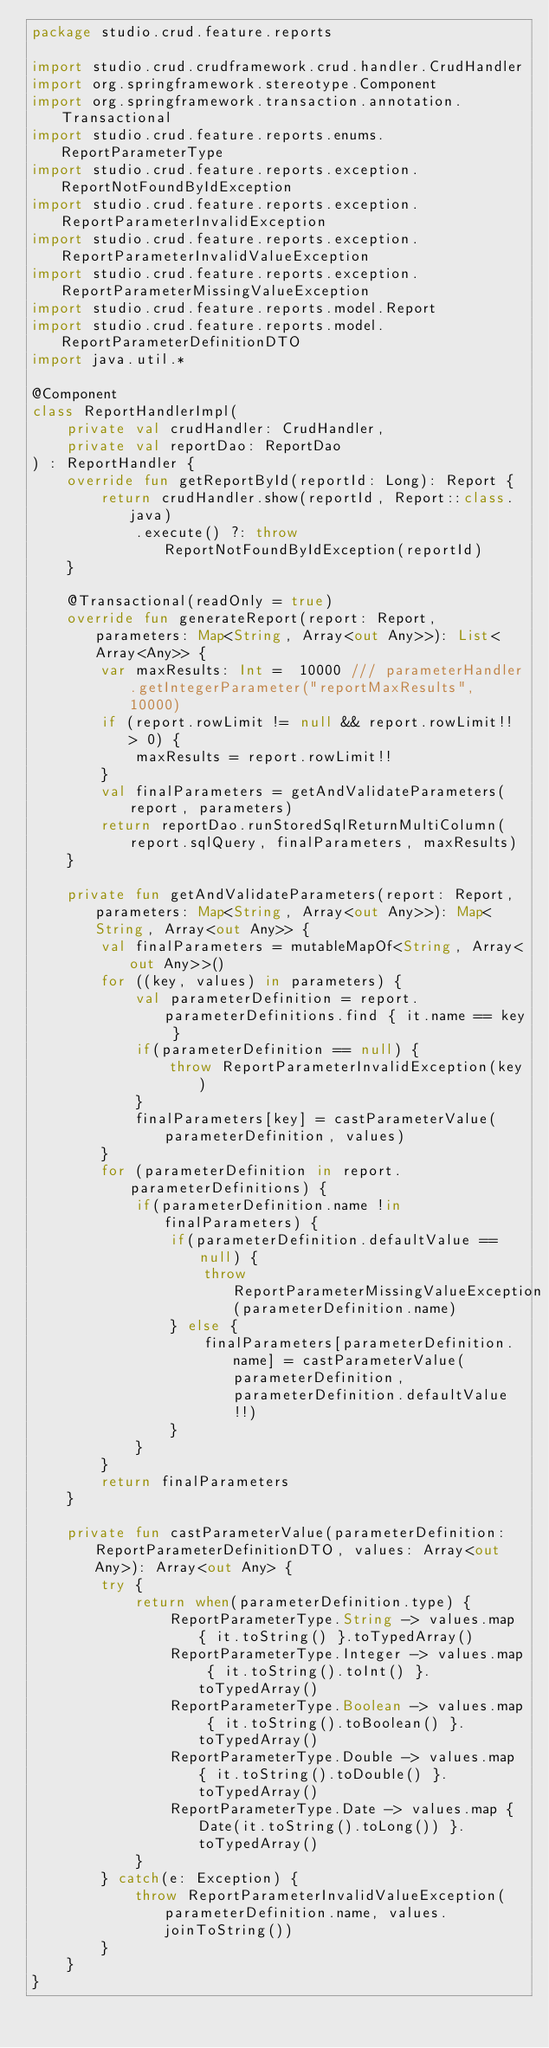<code> <loc_0><loc_0><loc_500><loc_500><_Kotlin_>package studio.crud.feature.reports

import studio.crud.crudframework.crud.handler.CrudHandler
import org.springframework.stereotype.Component
import org.springframework.transaction.annotation.Transactional
import studio.crud.feature.reports.enums.ReportParameterType
import studio.crud.feature.reports.exception.ReportNotFoundByIdException
import studio.crud.feature.reports.exception.ReportParameterInvalidException
import studio.crud.feature.reports.exception.ReportParameterInvalidValueException
import studio.crud.feature.reports.exception.ReportParameterMissingValueException
import studio.crud.feature.reports.model.Report
import studio.crud.feature.reports.model.ReportParameterDefinitionDTO
import java.util.*

@Component
class ReportHandlerImpl(
    private val crudHandler: CrudHandler,
    private val reportDao: ReportDao
) : ReportHandler {
    override fun getReportById(reportId: Long): Report {
        return crudHandler.show(reportId, Report::class.java)
            .execute() ?: throw ReportNotFoundByIdException(reportId)
    }

    @Transactional(readOnly = true)
    override fun generateReport(report: Report, parameters: Map<String, Array<out Any>>): List<Array<Any>> {
        var maxResults: Int =  10000 /// parameterHandler.getIntegerParameter("reportMaxResults", 10000)
        if (report.rowLimit != null && report.rowLimit!! > 0) {
            maxResults = report.rowLimit!!
        }
        val finalParameters = getAndValidateParameters(report, parameters)
        return reportDao.runStoredSqlReturnMultiColumn(report.sqlQuery, finalParameters, maxResults)
    }

    private fun getAndValidateParameters(report: Report, parameters: Map<String, Array<out Any>>): Map<String, Array<out Any>> {
        val finalParameters = mutableMapOf<String, Array<out Any>>()
        for ((key, values) in parameters) {
            val parameterDefinition = report.parameterDefinitions.find { it.name == key }
            if(parameterDefinition == null) {
                throw ReportParameterInvalidException(key)
            }
            finalParameters[key] = castParameterValue(parameterDefinition, values)
        }
        for (parameterDefinition in report.parameterDefinitions) {
            if(parameterDefinition.name !in finalParameters) {
                if(parameterDefinition.defaultValue == null) {
                    throw ReportParameterMissingValueException(parameterDefinition.name)
                } else {
                    finalParameters[parameterDefinition.name] = castParameterValue(parameterDefinition, parameterDefinition.defaultValue!!)
                }
            }
        }
        return finalParameters
    }

    private fun castParameterValue(parameterDefinition: ReportParameterDefinitionDTO, values: Array<out Any>): Array<out Any> {
        try {
            return when(parameterDefinition.type) {
                ReportParameterType.String -> values.map { it.toString() }.toTypedArray()
                ReportParameterType.Integer -> values.map { it.toString().toInt() }.toTypedArray()
                ReportParameterType.Boolean -> values.map { it.toString().toBoolean() }.toTypedArray()
                ReportParameterType.Double -> values.map { it.toString().toDouble() }.toTypedArray()
                ReportParameterType.Date -> values.map { Date(it.toString().toLong()) }.toTypedArray()
            }
        } catch(e: Exception) {
            throw ReportParameterInvalidValueException(parameterDefinition.name, values.joinToString())
        }
    }
}</code> 